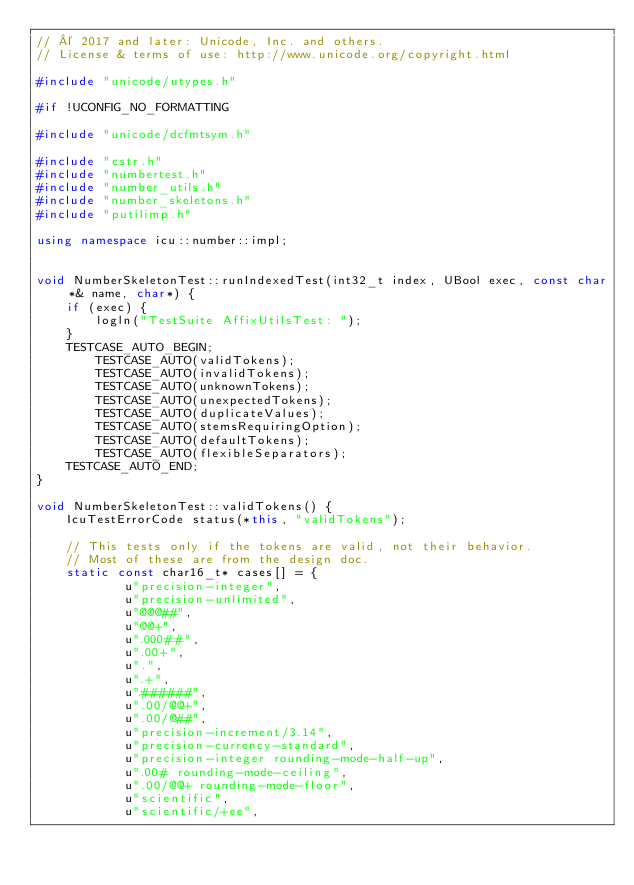Convert code to text. <code><loc_0><loc_0><loc_500><loc_500><_C++_>// © 2017 and later: Unicode, Inc. and others.
// License & terms of use: http://www.unicode.org/copyright.html

#include "unicode/utypes.h"

#if !UCONFIG_NO_FORMATTING

#include "unicode/dcfmtsym.h"

#include "cstr.h"
#include "numbertest.h"
#include "number_utils.h"
#include "number_skeletons.h"
#include "putilimp.h"

using namespace icu::number::impl;


void NumberSkeletonTest::runIndexedTest(int32_t index, UBool exec, const char*& name, char*) {
    if (exec) {
        logln("TestSuite AffixUtilsTest: ");
    }
    TESTCASE_AUTO_BEGIN;
        TESTCASE_AUTO(validTokens);
        TESTCASE_AUTO(invalidTokens);
        TESTCASE_AUTO(unknownTokens);
        TESTCASE_AUTO(unexpectedTokens);
        TESTCASE_AUTO(duplicateValues);
        TESTCASE_AUTO(stemsRequiringOption);
        TESTCASE_AUTO(defaultTokens);
        TESTCASE_AUTO(flexibleSeparators);
    TESTCASE_AUTO_END;
}

void NumberSkeletonTest::validTokens() {
    IcuTestErrorCode status(*this, "validTokens");

    // This tests only if the tokens are valid, not their behavior.
    // Most of these are from the design doc.
    static const char16_t* cases[] = {
            u"precision-integer",
            u"precision-unlimited",
            u"@@@##",
            u"@@+",
            u".000##",
            u".00+",
            u".",
            u".+",
            u".######",
            u".00/@@+",
            u".00/@##",
            u"precision-increment/3.14",
            u"precision-currency-standard",
            u"precision-integer rounding-mode-half-up",
            u".00# rounding-mode-ceiling",
            u".00/@@+ rounding-mode-floor",
            u"scientific",
            u"scientific/+ee",</code> 